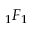Convert formula to latex. <formula><loc_0><loc_0><loc_500><loc_500>{ } _ { 1 } F _ { 1 }</formula> 